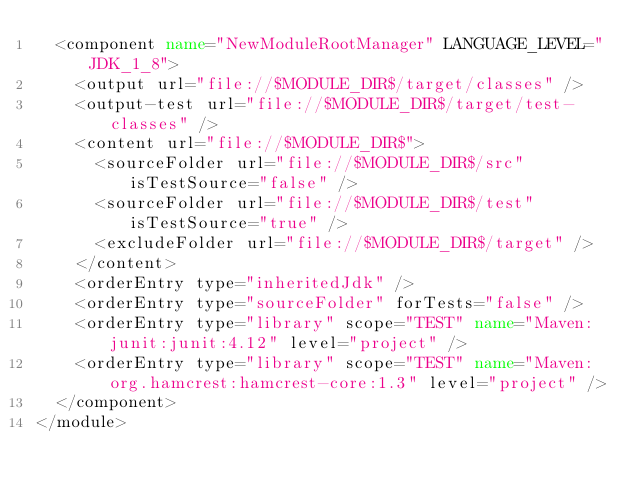<code> <loc_0><loc_0><loc_500><loc_500><_XML_>  <component name="NewModuleRootManager" LANGUAGE_LEVEL="JDK_1_8">
    <output url="file://$MODULE_DIR$/target/classes" />
    <output-test url="file://$MODULE_DIR$/target/test-classes" />
    <content url="file://$MODULE_DIR$">
      <sourceFolder url="file://$MODULE_DIR$/src" isTestSource="false" />
      <sourceFolder url="file://$MODULE_DIR$/test" isTestSource="true" />
      <excludeFolder url="file://$MODULE_DIR$/target" />
    </content>
    <orderEntry type="inheritedJdk" />
    <orderEntry type="sourceFolder" forTests="false" />
    <orderEntry type="library" scope="TEST" name="Maven: junit:junit:4.12" level="project" />
    <orderEntry type="library" scope="TEST" name="Maven: org.hamcrest:hamcrest-core:1.3" level="project" />
  </component>
</module></code> 